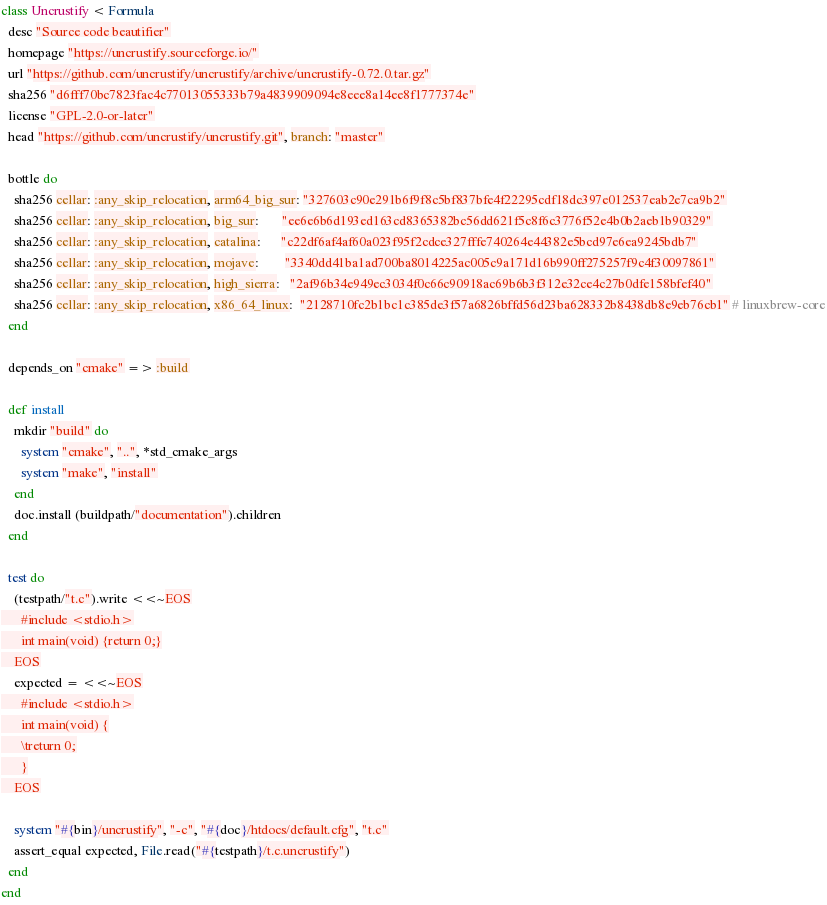<code> <loc_0><loc_0><loc_500><loc_500><_Ruby_>class Uncrustify < Formula
  desc "Source code beautifier"
  homepage "https://uncrustify.sourceforge.io/"
  url "https://github.com/uncrustify/uncrustify/archive/uncrustify-0.72.0.tar.gz"
  sha256 "d6fff70bc7823fac4c77013055333b79a4839909094e8eee8a14ee8f1777374e"
  license "GPL-2.0-or-later"
  head "https://github.com/uncrustify/uncrustify.git", branch: "master"

  bottle do
    sha256 cellar: :any_skip_relocation, arm64_big_sur: "327603c90e291b6f9f8c5bf837bfe4f22295cdf18dc397e012537eab2e7ca9b2"
    sha256 cellar: :any_skip_relocation, big_sur:       "ee6e6b6d193ed163cd8365382bc56dd621f5c8f6c3776f52e4b0b2aeb1b90329"
    sha256 cellar: :any_skip_relocation, catalina:      "c22df6af4af60a023f95f2cdce327fffe740264e44382e5bcd97e6ea9245bdb7"
    sha256 cellar: :any_skip_relocation, mojave:        "3340dd41ba1ad700ba8014225ac005c9a171d16b990ff275257f9c4f30097861"
    sha256 cellar: :any_skip_relocation, high_sierra:   "2af96b34e949ec3034f0c66c90918ac69b6b3f312e32ce4c27b0dfe158bfef40"
    sha256 cellar: :any_skip_relocation, x86_64_linux:  "2128710fc2b1bc1c385de3f57a6826bffd56d23ba628332b8438db8e9eb76cb1" # linuxbrew-core
  end

  depends_on "cmake" => :build

  def install
    mkdir "build" do
      system "cmake", "..", *std_cmake_args
      system "make", "install"
    end
    doc.install (buildpath/"documentation").children
  end

  test do
    (testpath/"t.c").write <<~EOS
      #include <stdio.h>
      int main(void) {return 0;}
    EOS
    expected = <<~EOS
      #include <stdio.h>
      int main(void) {
      \treturn 0;
      }
    EOS

    system "#{bin}/uncrustify", "-c", "#{doc}/htdocs/default.cfg", "t.c"
    assert_equal expected, File.read("#{testpath}/t.c.uncrustify")
  end
end
</code> 